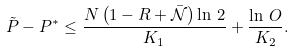<formula> <loc_0><loc_0><loc_500><loc_500>\tilde { P } - P ^ { * } \leq \frac { N \left ( 1 - R + \bar { \mathcal { N } } \right ) \ln \, 2 } { K _ { 1 } } + \frac { \ln \, O } { K _ { 2 } } .</formula> 